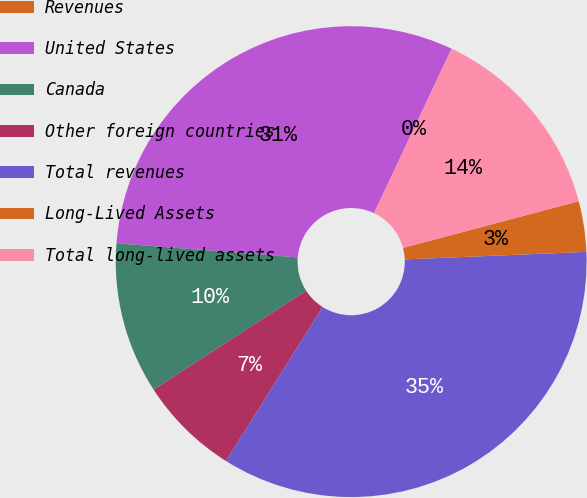<chart> <loc_0><loc_0><loc_500><loc_500><pie_chart><fcel>Revenues<fcel>United States<fcel>Canada<fcel>Other foreign countries<fcel>Total revenues<fcel>Long-Lived Assets<fcel>Total long-lived assets<nl><fcel>0.02%<fcel>30.76%<fcel>10.39%<fcel>6.93%<fcel>34.58%<fcel>3.47%<fcel>13.84%<nl></chart> 